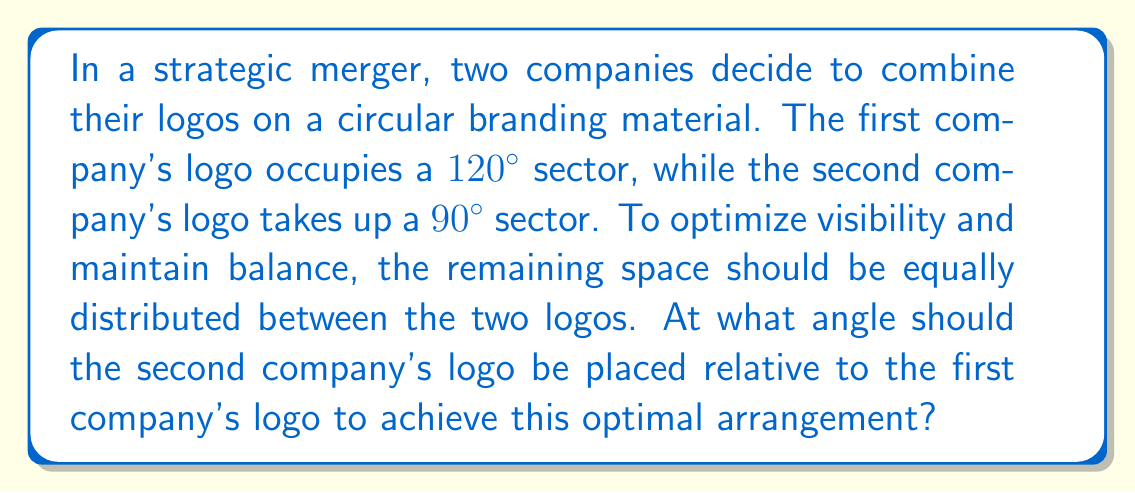Can you answer this question? Let's approach this step-by-step:

1) First, let's calculate the total angle occupied by both logos:
   $120° + 90° = 210°$

2) The remaining space in the circle is:
   $360° - 210° = 150°$

3) This remaining space should be equally distributed between the two logos. So, we divide it by 2:
   $150° ÷ 2 = 75°$

4) Now, we need to place the second logo at an angle that allows for 75° on each side. This means the angle between the end of the first logo and the start of the second logo should be 75°.

5) The optimal angle for placing the second logo relative to the first is:
   $120° + 75° = 195°$

Here's a visual representation:

[asy]
import geometry;

size(200);
path circle = Circle((0,0), 1);
draw(circle);

draw(arc((0,0), 1, 0, 120), blue+1);
draw(arc((0,0), 1, 195, 285), red+1);

label("120°", (0.7,0.4), blue);
label("90°", (-0.7,-0.4), red);
label("75°", (0,-0.7));
label("75°", (-0.3,0.7));

draw((0,0)--dir(0), dashed);
draw((0,0)--dir(120), dashed);
draw((0,0)--dir(195), dashed);
draw((0,0)--dir(285), dashed);
[/asy]

This arrangement ensures that the logos are optimally spaced, maintaining balance and maximizing visibility for both companies in the merged branding material.
Answer: 195° 